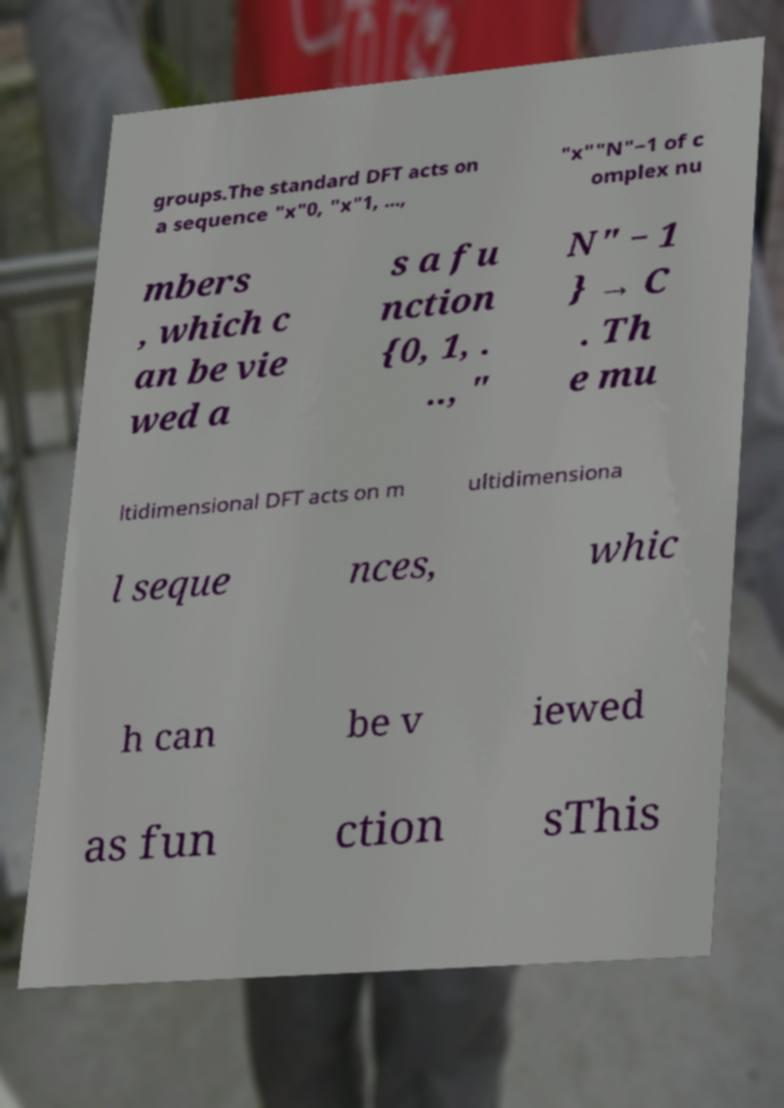Please read and relay the text visible in this image. What does it say? groups.The standard DFT acts on a sequence "x"0, "x"1, ..., "x""N"−1 of c omplex nu mbers , which c an be vie wed a s a fu nction {0, 1, . .., " N" − 1 } → C . Th e mu ltidimensional DFT acts on m ultidimensiona l seque nces, whic h can be v iewed as fun ction sThis 